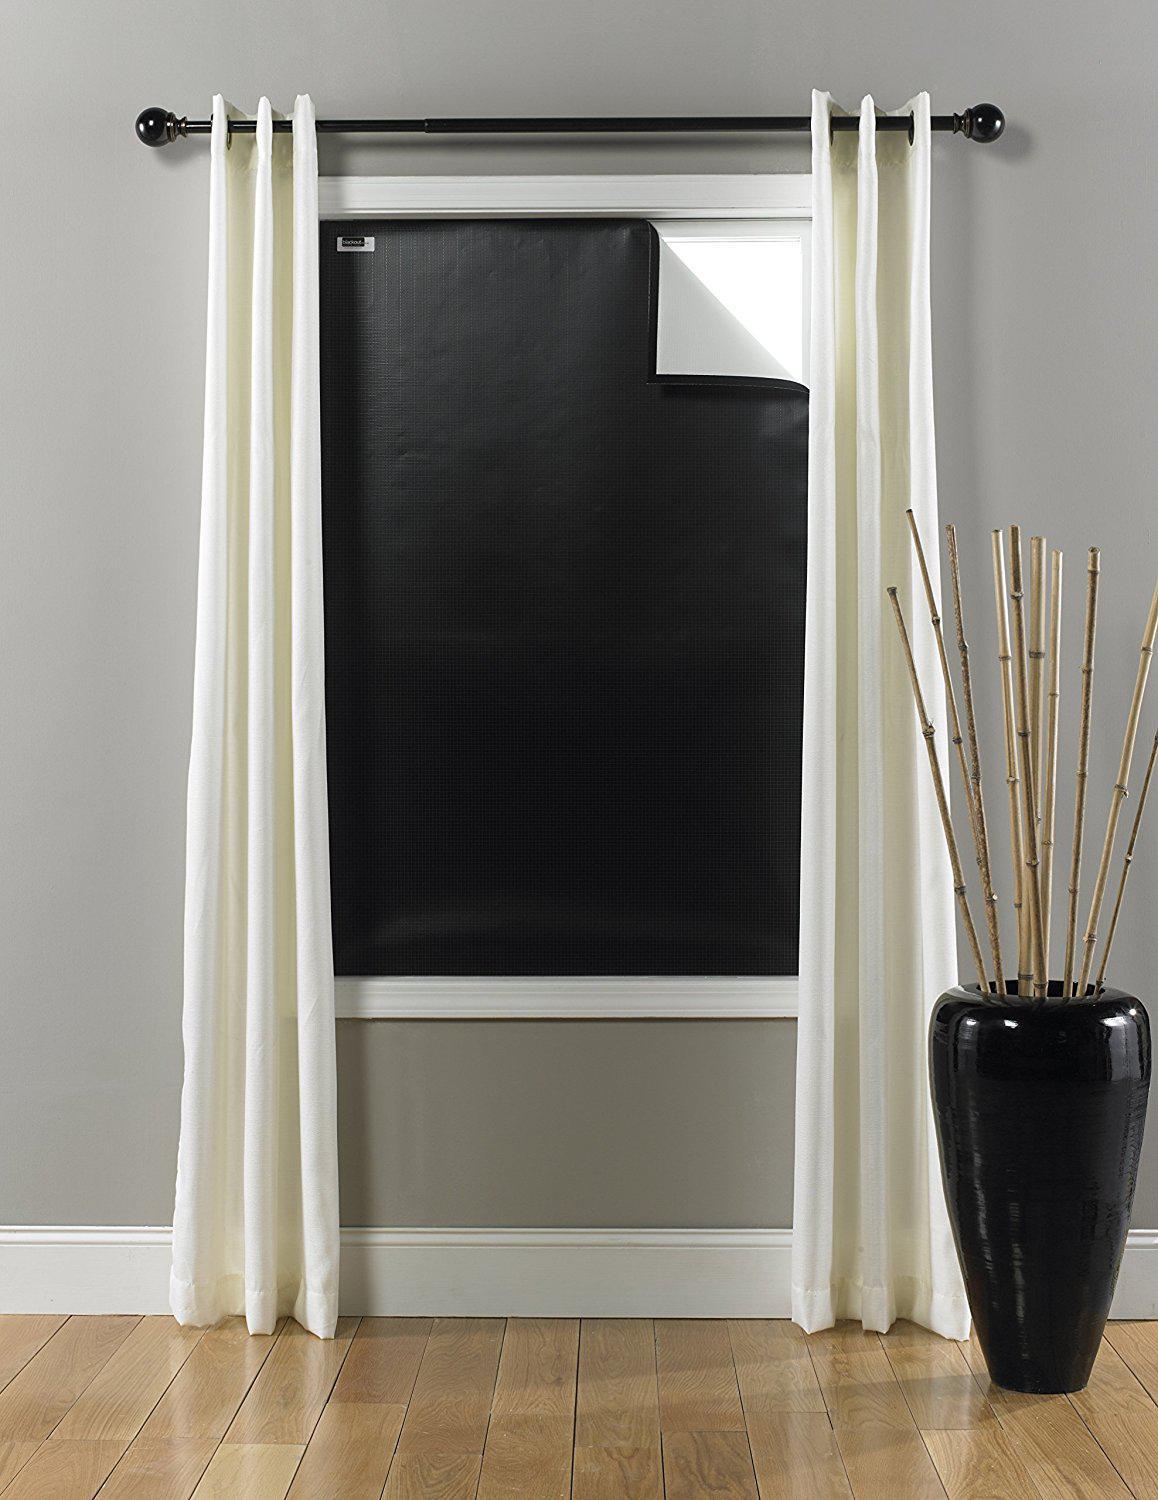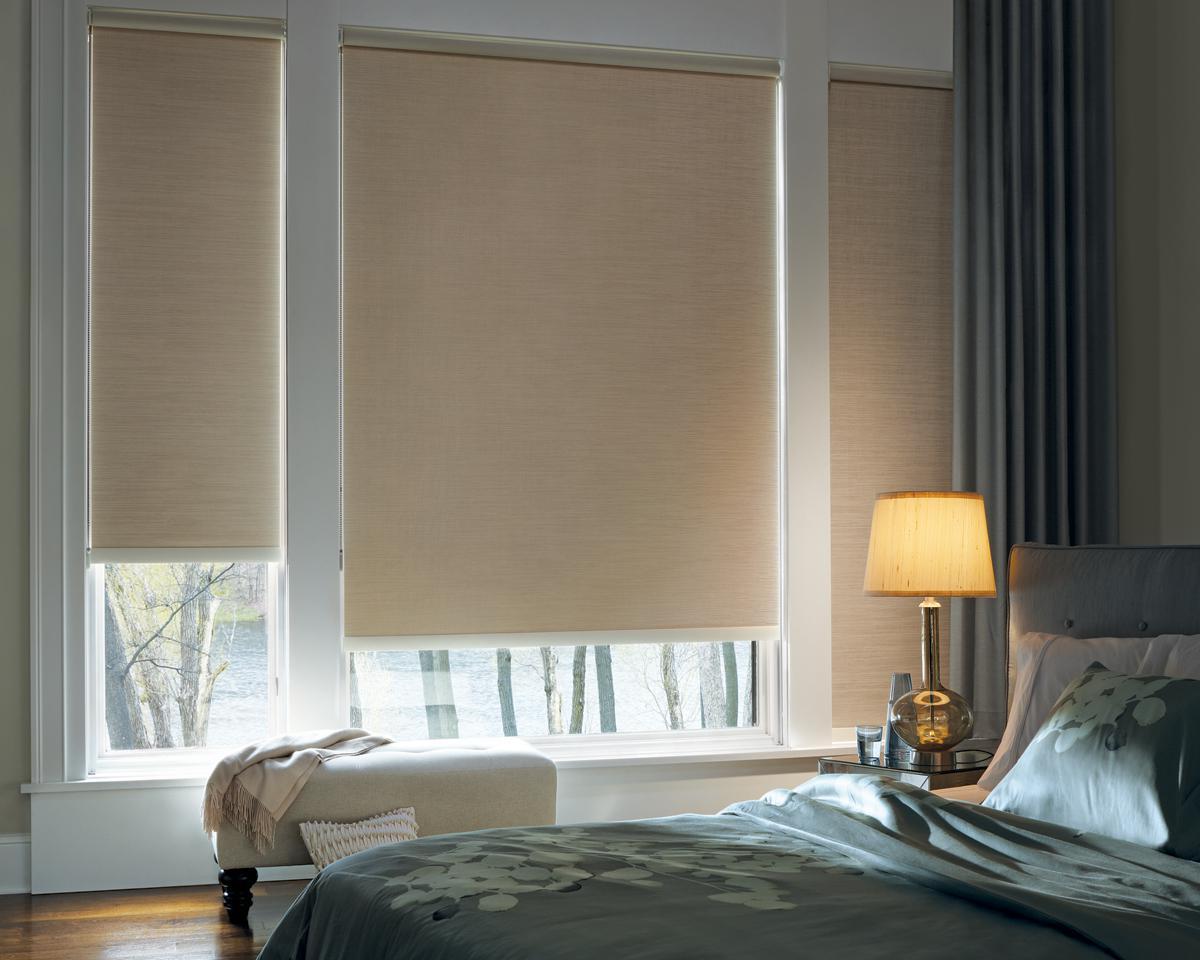The first image is the image on the left, the second image is the image on the right. Examine the images to the left and right. Is the description "An image shows three neutral-colored shades in a row on a straight wall, each covering at least 2/3 of a pane-less window." accurate? Answer yes or no. Yes. The first image is the image on the left, the second image is the image on the right. Given the left and right images, does the statement "all the shades in the right image are partially open." hold true? Answer yes or no. No. 